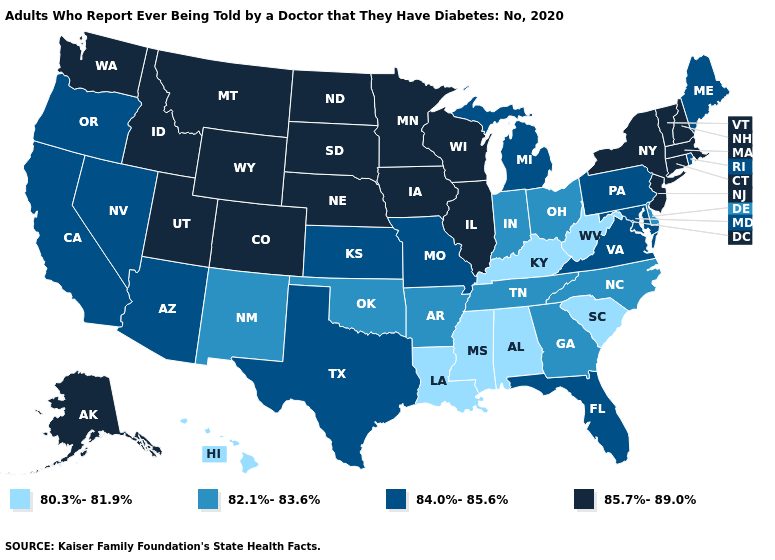Name the states that have a value in the range 84.0%-85.6%?
Short answer required. Arizona, California, Florida, Kansas, Maine, Maryland, Michigan, Missouri, Nevada, Oregon, Pennsylvania, Rhode Island, Texas, Virginia. Name the states that have a value in the range 80.3%-81.9%?
Write a very short answer. Alabama, Hawaii, Kentucky, Louisiana, Mississippi, South Carolina, West Virginia. Name the states that have a value in the range 84.0%-85.6%?
Short answer required. Arizona, California, Florida, Kansas, Maine, Maryland, Michigan, Missouri, Nevada, Oregon, Pennsylvania, Rhode Island, Texas, Virginia. What is the value of Texas?
Short answer required. 84.0%-85.6%. What is the highest value in the USA?
Write a very short answer. 85.7%-89.0%. Does the map have missing data?
Answer briefly. No. Which states have the highest value in the USA?
Quick response, please. Alaska, Colorado, Connecticut, Idaho, Illinois, Iowa, Massachusetts, Minnesota, Montana, Nebraska, New Hampshire, New Jersey, New York, North Dakota, South Dakota, Utah, Vermont, Washington, Wisconsin, Wyoming. What is the lowest value in the USA?
Short answer required. 80.3%-81.9%. Which states hav the highest value in the South?
Give a very brief answer. Florida, Maryland, Texas, Virginia. Which states have the lowest value in the MidWest?
Quick response, please. Indiana, Ohio. Does New Jersey have the lowest value in the USA?
Answer briefly. No. What is the value of Montana?
Give a very brief answer. 85.7%-89.0%. Which states have the highest value in the USA?
Keep it brief. Alaska, Colorado, Connecticut, Idaho, Illinois, Iowa, Massachusetts, Minnesota, Montana, Nebraska, New Hampshire, New Jersey, New York, North Dakota, South Dakota, Utah, Vermont, Washington, Wisconsin, Wyoming. Which states have the highest value in the USA?
Write a very short answer. Alaska, Colorado, Connecticut, Idaho, Illinois, Iowa, Massachusetts, Minnesota, Montana, Nebraska, New Hampshire, New Jersey, New York, North Dakota, South Dakota, Utah, Vermont, Washington, Wisconsin, Wyoming. 